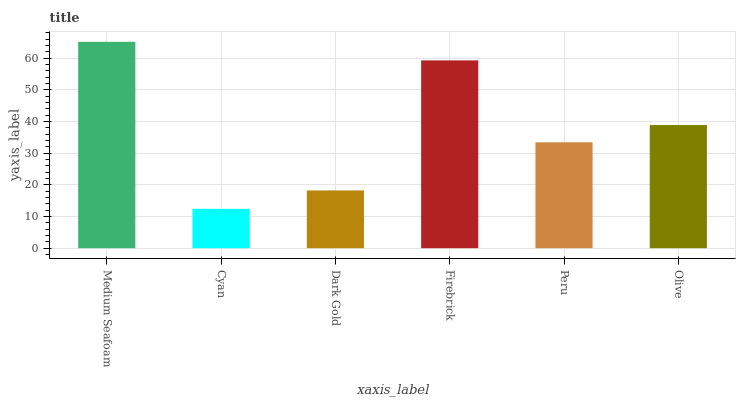Is Dark Gold the minimum?
Answer yes or no. No. Is Dark Gold the maximum?
Answer yes or no. No. Is Dark Gold greater than Cyan?
Answer yes or no. Yes. Is Cyan less than Dark Gold?
Answer yes or no. Yes. Is Cyan greater than Dark Gold?
Answer yes or no. No. Is Dark Gold less than Cyan?
Answer yes or no. No. Is Olive the high median?
Answer yes or no. Yes. Is Peru the low median?
Answer yes or no. Yes. Is Medium Seafoam the high median?
Answer yes or no. No. Is Firebrick the low median?
Answer yes or no. No. 